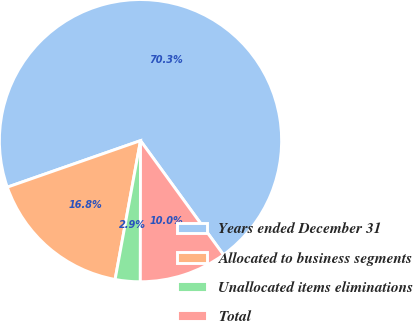Convert chart. <chart><loc_0><loc_0><loc_500><loc_500><pie_chart><fcel>Years ended December 31<fcel>Allocated to business segments<fcel>Unallocated items eliminations<fcel>Total<nl><fcel>70.34%<fcel>16.77%<fcel>2.86%<fcel>10.02%<nl></chart> 